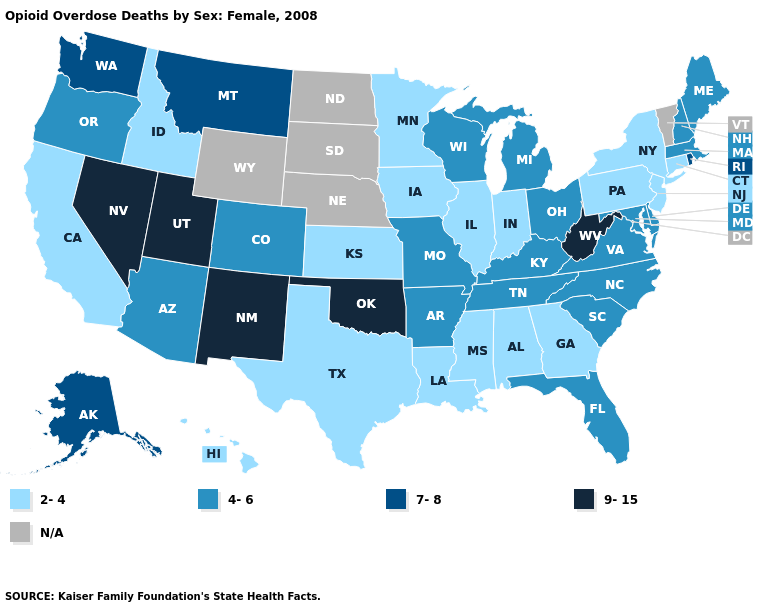Name the states that have a value in the range 4-6?
Keep it brief. Arizona, Arkansas, Colorado, Delaware, Florida, Kentucky, Maine, Maryland, Massachusetts, Michigan, Missouri, New Hampshire, North Carolina, Ohio, Oregon, South Carolina, Tennessee, Virginia, Wisconsin. Does the map have missing data?
Answer briefly. Yes. Does the map have missing data?
Concise answer only. Yes. What is the lowest value in the South?
Keep it brief. 2-4. What is the highest value in the USA?
Be succinct. 9-15. What is the lowest value in the MidWest?
Give a very brief answer. 2-4. Which states have the lowest value in the MidWest?
Be succinct. Illinois, Indiana, Iowa, Kansas, Minnesota. Name the states that have a value in the range 2-4?
Keep it brief. Alabama, California, Connecticut, Georgia, Hawaii, Idaho, Illinois, Indiana, Iowa, Kansas, Louisiana, Minnesota, Mississippi, New Jersey, New York, Pennsylvania, Texas. What is the highest value in the Northeast ?
Short answer required. 7-8. What is the value of South Carolina?
Write a very short answer. 4-6. Is the legend a continuous bar?
Concise answer only. No. What is the value of Illinois?
Concise answer only. 2-4. Which states have the highest value in the USA?
Keep it brief. Nevada, New Mexico, Oklahoma, Utah, West Virginia. Name the states that have a value in the range 9-15?
Write a very short answer. Nevada, New Mexico, Oklahoma, Utah, West Virginia. Which states have the lowest value in the USA?
Concise answer only. Alabama, California, Connecticut, Georgia, Hawaii, Idaho, Illinois, Indiana, Iowa, Kansas, Louisiana, Minnesota, Mississippi, New Jersey, New York, Pennsylvania, Texas. 